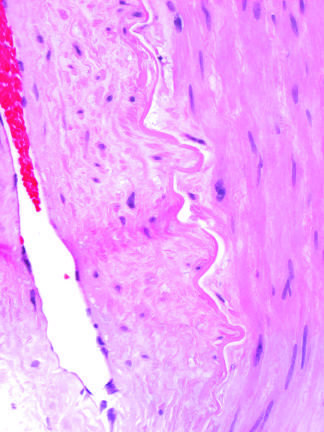what is produced by radiation therapy of the neck region?
Answer the question using a single word or phrase. Bile duct cells and canals of hering 